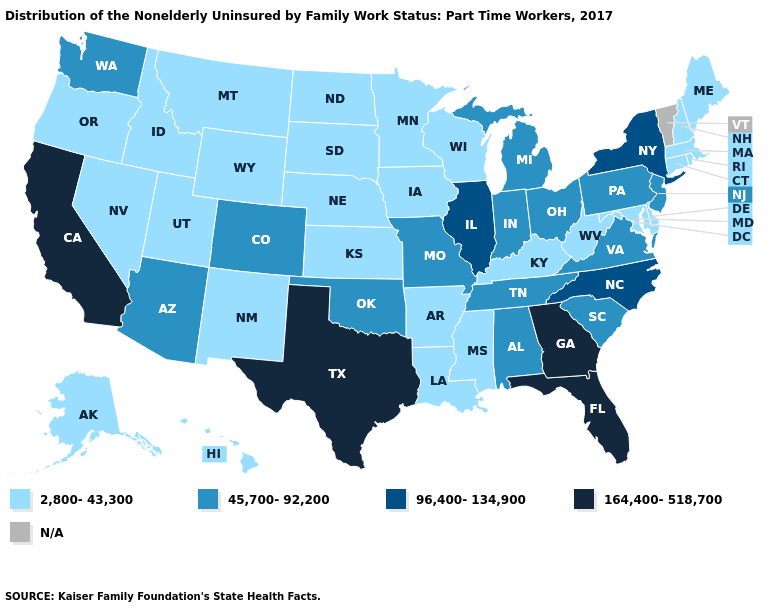Name the states that have a value in the range 164,400-518,700?
Be succinct. California, Florida, Georgia, Texas. What is the value of Kentucky?
Give a very brief answer. 2,800-43,300. Does Montana have the highest value in the USA?
Short answer required. No. What is the highest value in states that border South Dakota?
Give a very brief answer. 2,800-43,300. Does Colorado have the highest value in the West?
Write a very short answer. No. Which states have the lowest value in the Northeast?
Quick response, please. Connecticut, Maine, Massachusetts, New Hampshire, Rhode Island. What is the value of Missouri?
Quick response, please. 45,700-92,200. Which states have the lowest value in the West?
Quick response, please. Alaska, Hawaii, Idaho, Montana, Nevada, New Mexico, Oregon, Utah, Wyoming. What is the lowest value in the USA?
Concise answer only. 2,800-43,300. What is the value of Louisiana?
Short answer required. 2,800-43,300. What is the value of North Dakota?
Concise answer only. 2,800-43,300. What is the lowest value in the Northeast?
Short answer required. 2,800-43,300. How many symbols are there in the legend?
Answer briefly. 5. Does Texas have the highest value in the South?
Be succinct. Yes. 